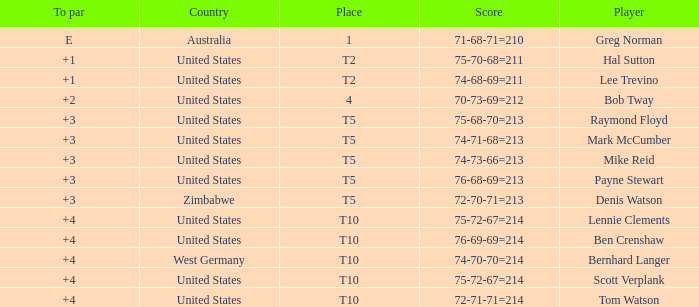What is player raymond floyd's country? United States. 